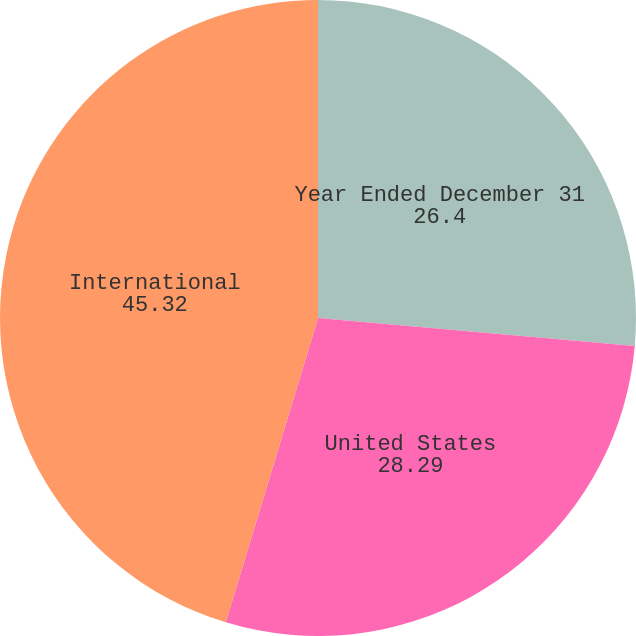Convert chart to OTSL. <chart><loc_0><loc_0><loc_500><loc_500><pie_chart><fcel>Year Ended December 31<fcel>United States<fcel>International<nl><fcel>26.4%<fcel>28.29%<fcel>45.32%<nl></chart> 